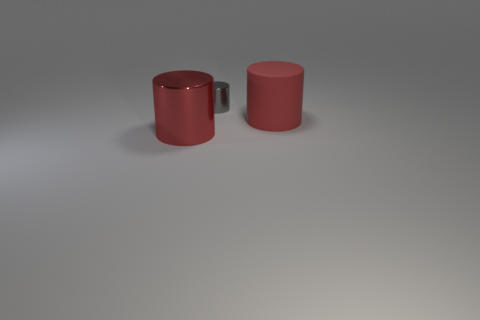Are there any other things that have the same size as the gray thing?
Your answer should be very brief. No. There is a large metal object that is the same color as the large matte cylinder; what is its shape?
Offer a terse response. Cylinder. How many things are there?
Provide a short and direct response. 3. How many other large things are the same shape as the matte thing?
Keep it short and to the point. 1. Is the shape of the small object the same as the red rubber object?
Provide a short and direct response. Yes. The gray metallic cylinder is what size?
Your answer should be very brief. Small. What number of other gray shiny things are the same size as the gray thing?
Offer a very short reply. 0. Does the gray cylinder that is behind the large red shiny cylinder have the same size as the object in front of the big red rubber cylinder?
Your answer should be very brief. No. There is a red thing that is to the right of the large metallic cylinder; what shape is it?
Your answer should be very brief. Cylinder. There is a red object that is to the right of the red metal thing that is to the left of the large matte cylinder; what is it made of?
Offer a very short reply. Rubber. 